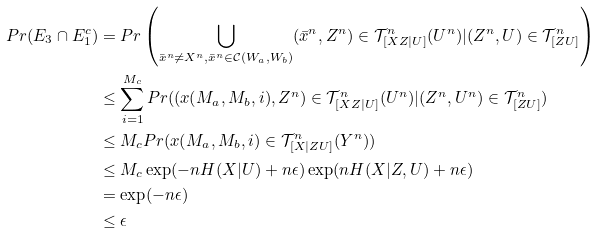<formula> <loc_0><loc_0><loc_500><loc_500>P r ( E _ { 3 } \cap E _ { 1 } ^ { c } ) & = P r \left ( \bigcup _ { \bar { x } ^ { n } \ne X ^ { n } , \bar { x } ^ { n } \in \mathcal { C } ( W _ { a } , W _ { b } ) } ( \bar { x } ^ { n } , Z ^ { n } ) \in \mathcal { T } _ { [ X Z | U ] } ^ { n } ( U ^ { n } ) | ( Z ^ { n } , U ) \in \mathcal { T } _ { [ Z U ] } ^ { n } \right ) \\ & \leq \sum _ { i = 1 } ^ { M _ { c } } P r ( ( x ( M _ { a } , M _ { b } , i ) , Z ^ { n } ) \in \mathcal { T } _ { [ X Z | U ] } ^ { n } ( U ^ { n } ) | ( Z ^ { n } , U ^ { n } ) \in \mathcal { T } _ { [ Z U ] } ^ { n } ) \\ & \leq M _ { c } P r ( x ( M _ { a } , M _ { b } , i ) \in \mathcal { T } _ { [ X | Z U ] } ^ { n } ( Y ^ { n } ) ) \\ & \leq M _ { c } \exp ( - n H ( X | U ) + n \epsilon ) \exp ( n H ( X | Z , U ) + n \epsilon ) \\ & = \exp ( - n \epsilon ) \\ & \leq \epsilon</formula> 